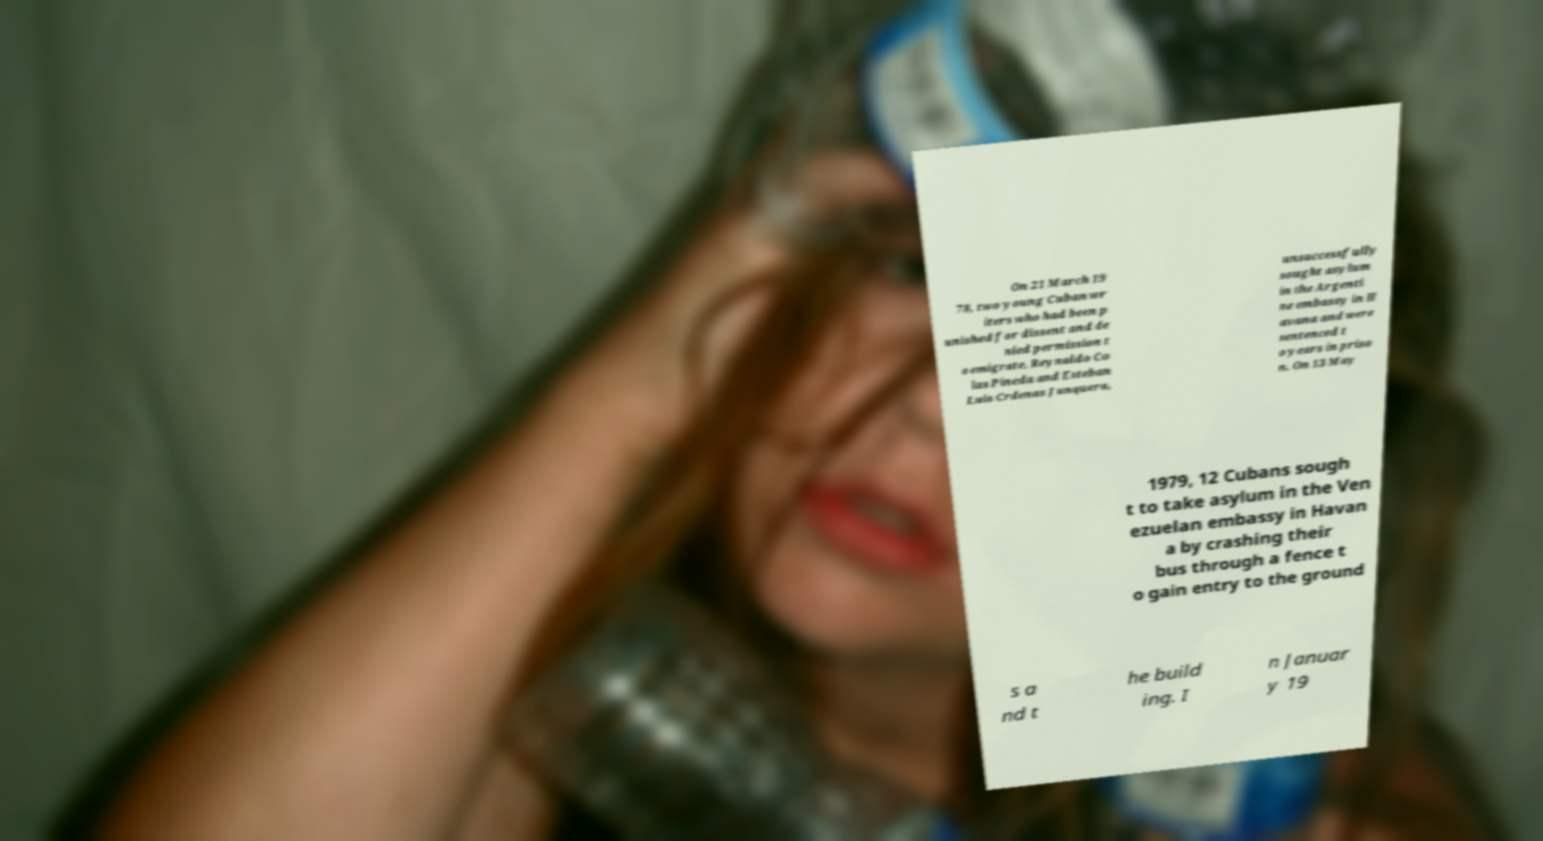What messages or text are displayed in this image? I need them in a readable, typed format. On 21 March 19 78, two young Cuban wr iters who had been p unished for dissent and de nied permission t o emigrate, Reynaldo Co las Pineda and Esteban Luis Crdenas Junquera, unsuccessfully sought asylum in the Argenti ne embassy in H avana and were sentenced t o years in priso n. On 13 May 1979, 12 Cubans sough t to take asylum in the Ven ezuelan embassy in Havan a by crashing their bus through a fence t o gain entry to the ground s a nd t he build ing. I n Januar y 19 